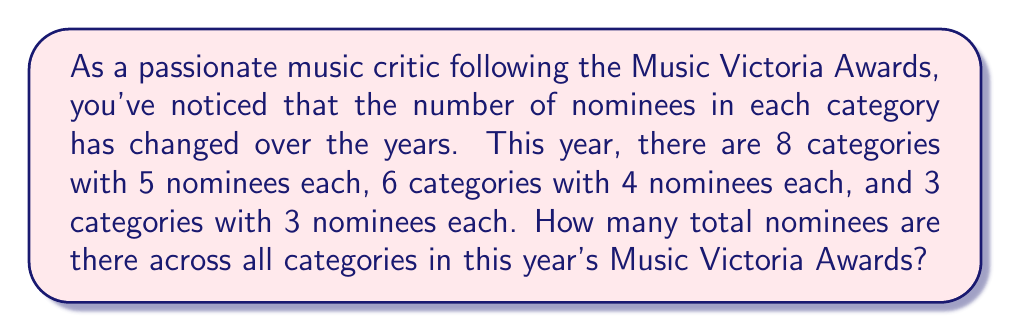Give your solution to this math problem. To solve this problem, we need to calculate the total number of nominees across all categories. Let's break it down step-by-step:

1. Categories with 5 nominees each:
   - Number of categories: 8
   - Number of nominees per category: 5
   - Total nominees: $8 \times 5 = 40$

2. Categories with 4 nominees each:
   - Number of categories: 6
   - Number of nominees per category: 4
   - Total nominees: $6 \times 4 = 24$

3. Categories with 3 nominees each:
   - Number of categories: 3
   - Number of nominees per category: 3
   - Total nominees: $3 \times 3 = 9$

Now, we sum up the nominees from all category types:

$$\text{Total nominees} = 40 + 24 + 9 = 73$$

Therefore, the total number of nominees across all categories in this year's Music Victoria Awards is 73.
Answer: 73 nominees 